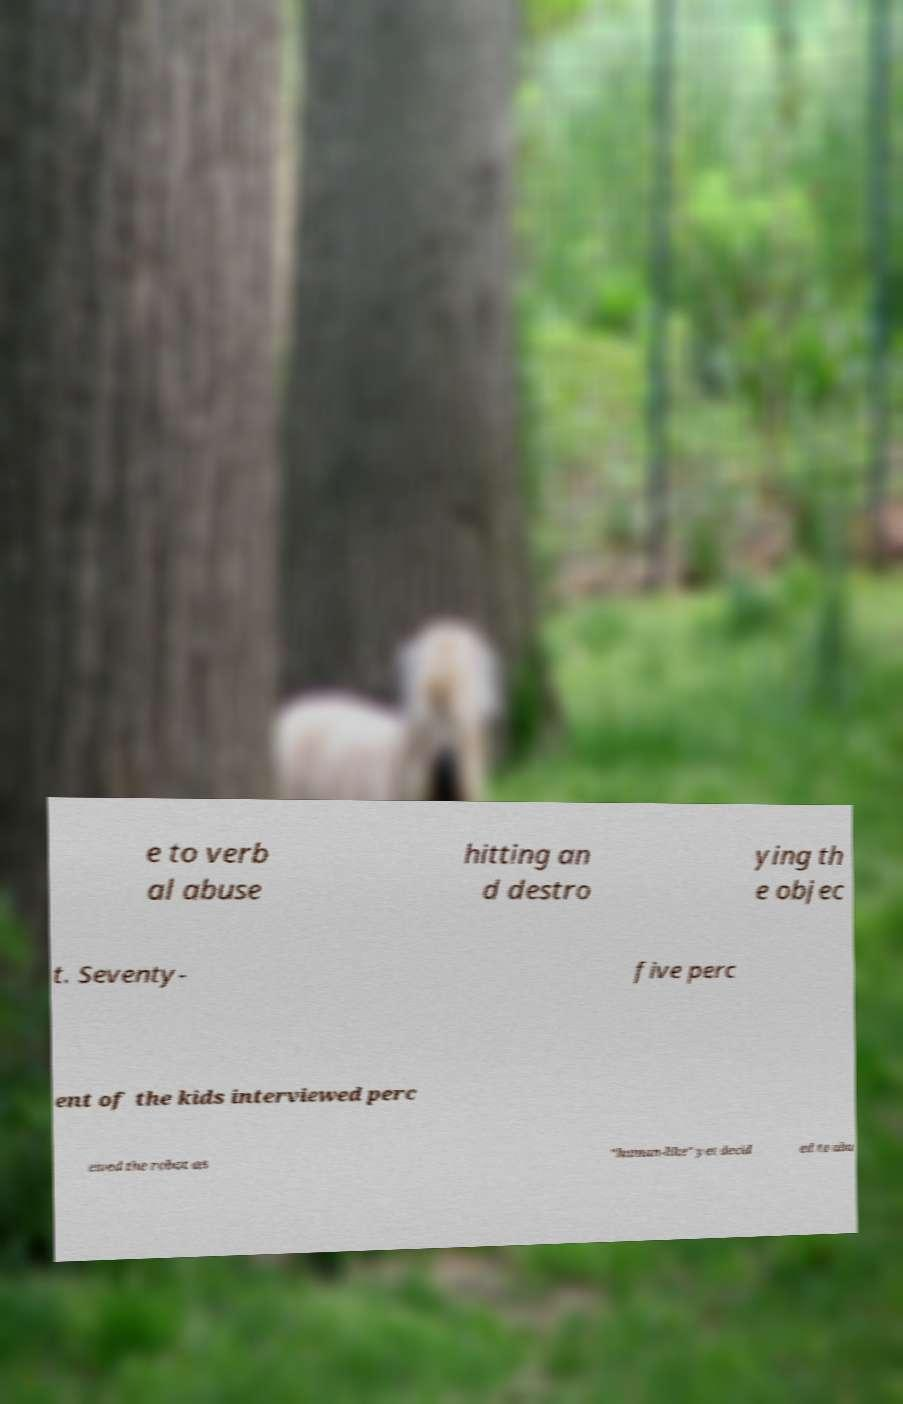Could you extract and type out the text from this image? e to verb al abuse hitting an d destro ying th e objec t. Seventy- five perc ent of the kids interviewed perc eived the robot as "human-like" yet decid ed to abu 